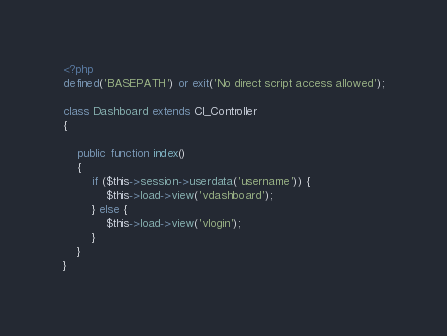<code> <loc_0><loc_0><loc_500><loc_500><_PHP_><?php
defined('BASEPATH') or exit('No direct script access allowed');

class Dashboard extends CI_Controller
{

    public function index()
    {
        if ($this->session->userdata('username')) {
            $this->load->view('vdashboard');
        } else {
            $this->load->view('vlogin');
        }
    }
}
</code> 